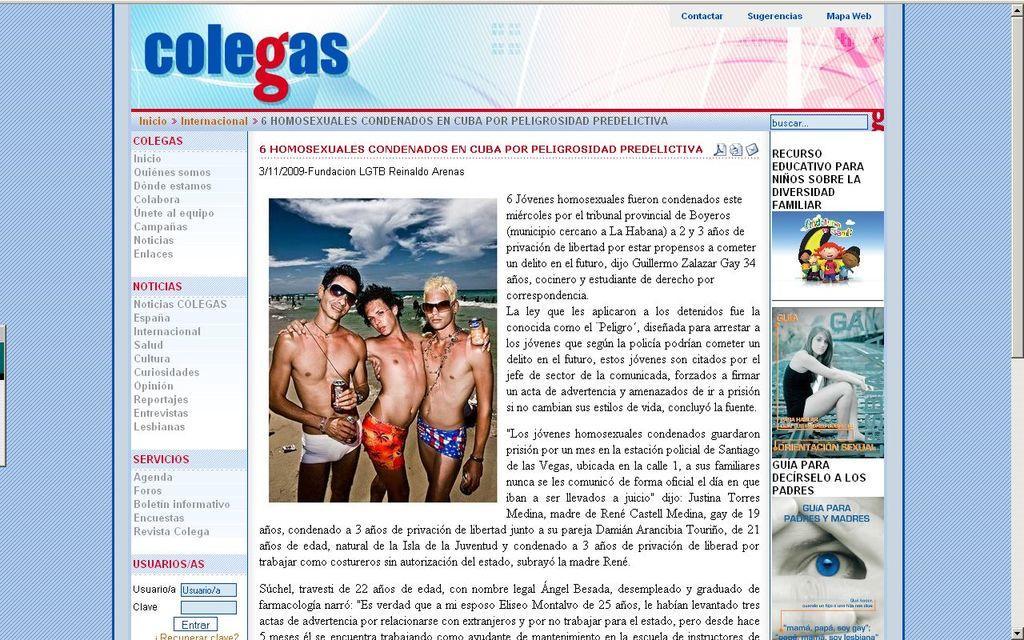Could you give a brief overview of what you see in this image? In this picture we can see screen, in this screen we can see people and some information. 